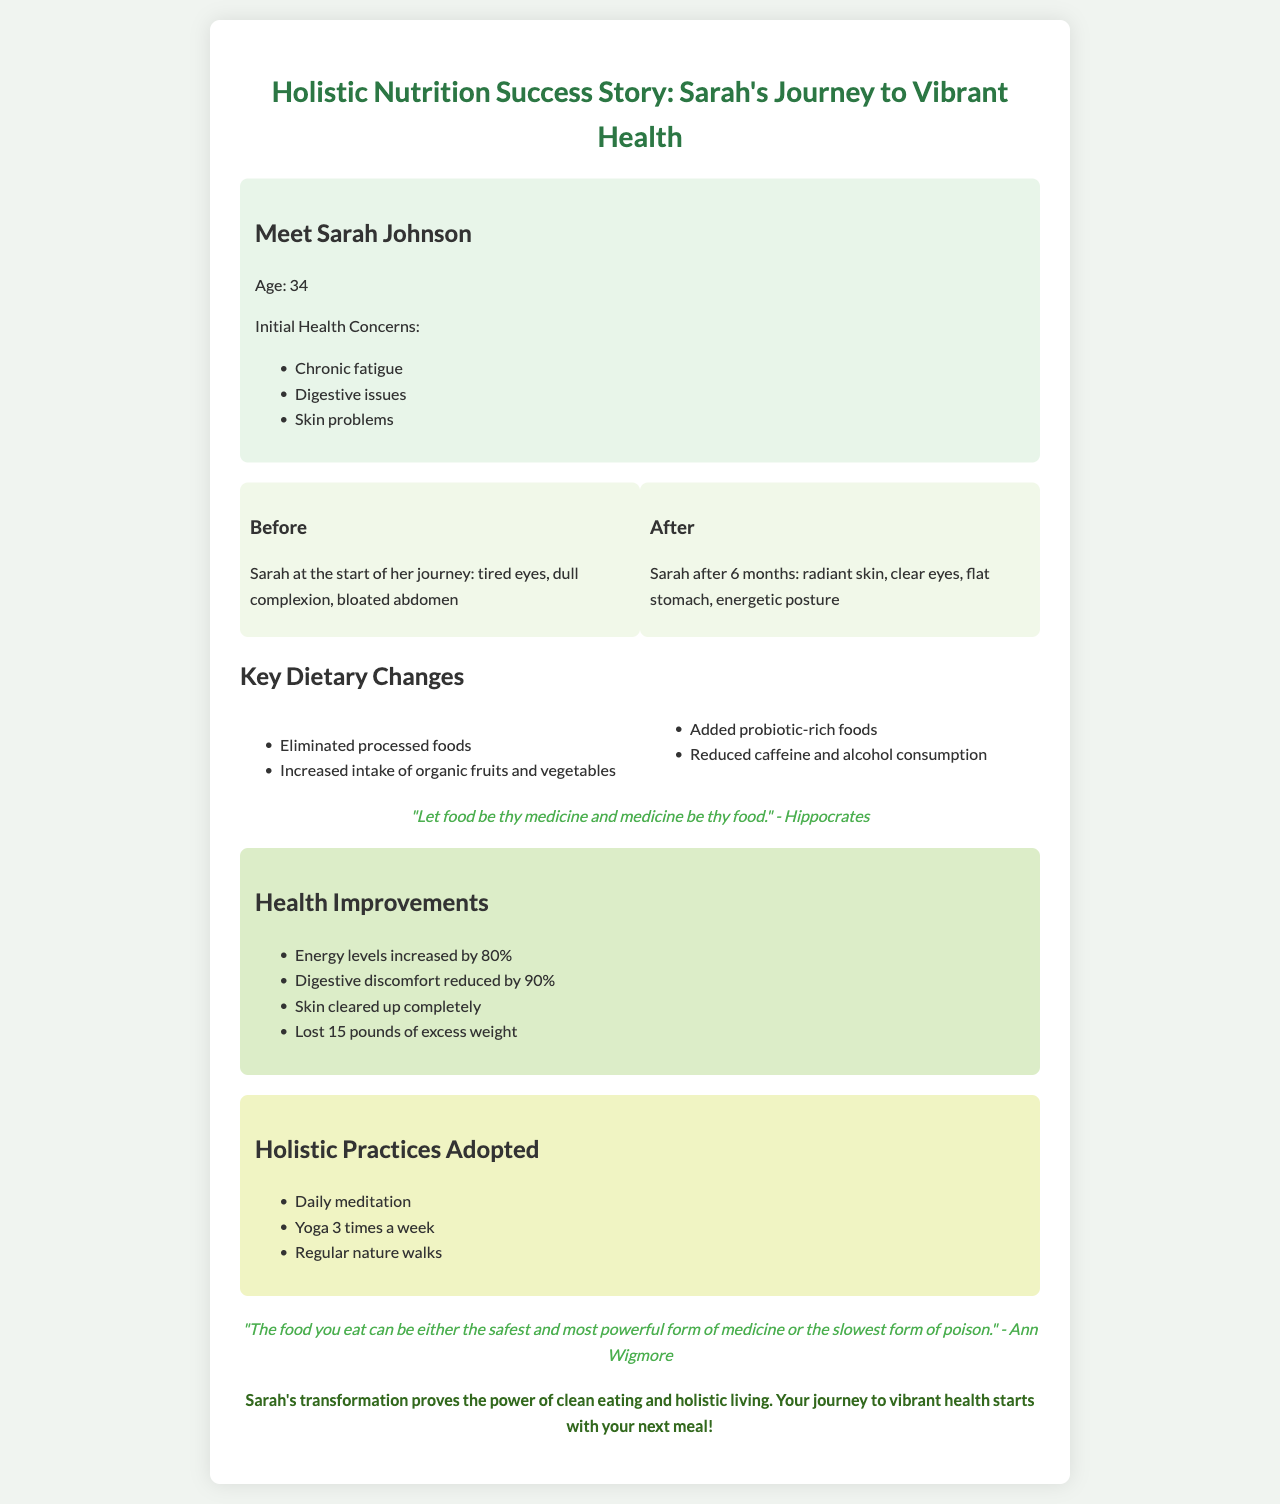What are Sarah's initial health concerns? The initial health concerns include chronic fatigue, digestive issues, and skin problems as listed under client info.
Answer: Chronic fatigue, digestive issues, skin problems How many pounds did Sarah lose? The document mentions that Sarah lost 15 pounds of excess weight in the improvements section.
Answer: 15 pounds What was Sarah's age when she started her journey? The document states Sarah’s age as 34 in the client info section.
Answer: 34 What percentage did Sarah's energy levels increase? The document states that energy levels increased by 80% in the health improvements section.
Answer: 80% What holistic practice did Sarah adopt three times a week? The document mentions yoga as a holistic practice that is done 3 times a week in the holistic practices section.
Answer: Yoga What significant dietary change did Sarah make regarding processed foods? The document states that Sarah eliminated processed foods as part of her key dietary changes.
Answer: Eliminated processed foods Which quote is attributed to Hippocrates in the document? The document quotes Hippocrates saying "Let food be thy medicine and medicine be thy food."
Answer: "Let food be thy medicine and medicine be thy food." What improvements did Sarah notice in her skin? The improvements section notes that Sarah's skin cleared up completely.
Answer: Cleared up completely 